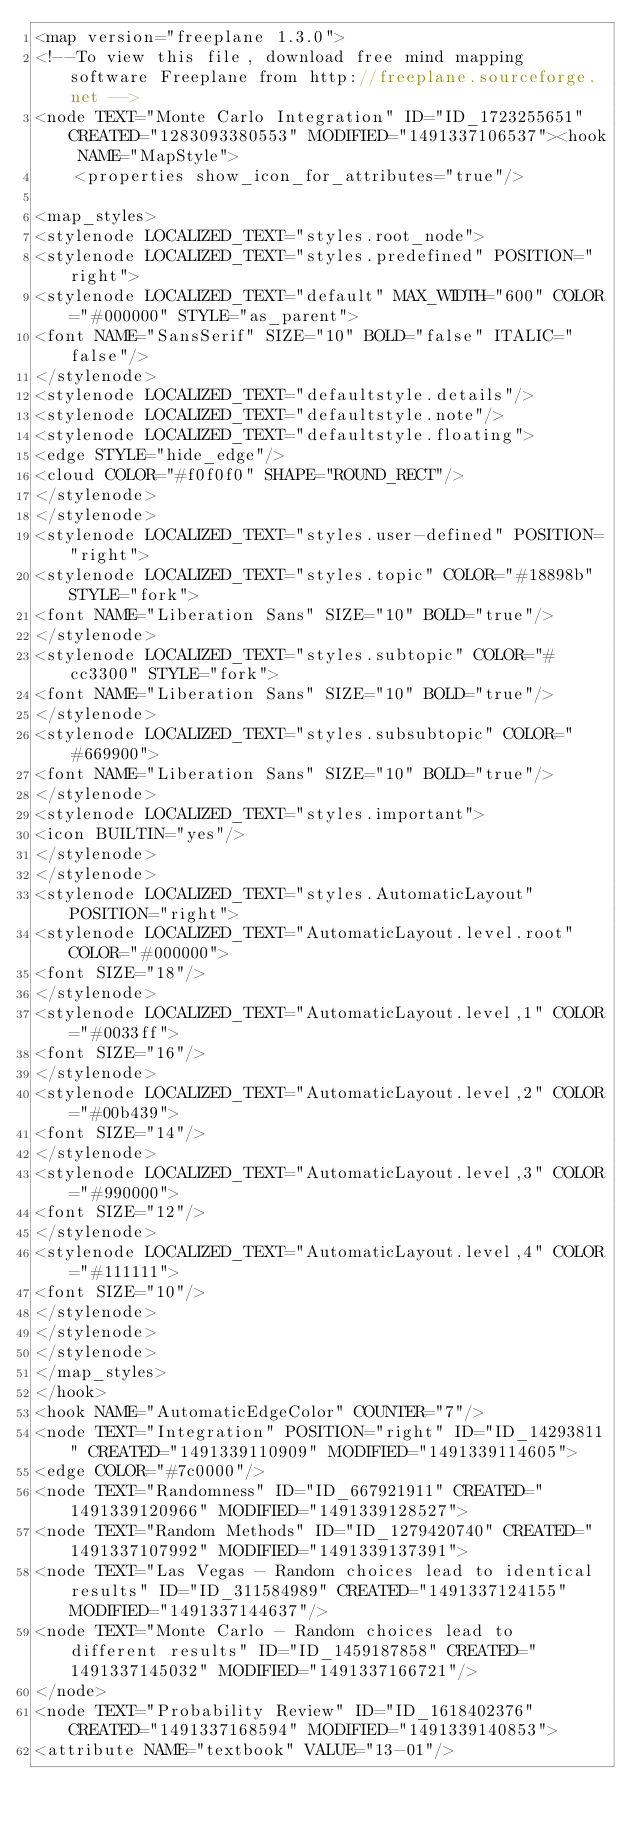<code> <loc_0><loc_0><loc_500><loc_500><_ObjectiveC_><map version="freeplane 1.3.0">
<!--To view this file, download free mind mapping software Freeplane from http://freeplane.sourceforge.net -->
<node TEXT="Monte Carlo Integration" ID="ID_1723255651" CREATED="1283093380553" MODIFIED="1491337106537"><hook NAME="MapStyle">
    <properties show_icon_for_attributes="true"/>

<map_styles>
<stylenode LOCALIZED_TEXT="styles.root_node">
<stylenode LOCALIZED_TEXT="styles.predefined" POSITION="right">
<stylenode LOCALIZED_TEXT="default" MAX_WIDTH="600" COLOR="#000000" STYLE="as_parent">
<font NAME="SansSerif" SIZE="10" BOLD="false" ITALIC="false"/>
</stylenode>
<stylenode LOCALIZED_TEXT="defaultstyle.details"/>
<stylenode LOCALIZED_TEXT="defaultstyle.note"/>
<stylenode LOCALIZED_TEXT="defaultstyle.floating">
<edge STYLE="hide_edge"/>
<cloud COLOR="#f0f0f0" SHAPE="ROUND_RECT"/>
</stylenode>
</stylenode>
<stylenode LOCALIZED_TEXT="styles.user-defined" POSITION="right">
<stylenode LOCALIZED_TEXT="styles.topic" COLOR="#18898b" STYLE="fork">
<font NAME="Liberation Sans" SIZE="10" BOLD="true"/>
</stylenode>
<stylenode LOCALIZED_TEXT="styles.subtopic" COLOR="#cc3300" STYLE="fork">
<font NAME="Liberation Sans" SIZE="10" BOLD="true"/>
</stylenode>
<stylenode LOCALIZED_TEXT="styles.subsubtopic" COLOR="#669900">
<font NAME="Liberation Sans" SIZE="10" BOLD="true"/>
</stylenode>
<stylenode LOCALIZED_TEXT="styles.important">
<icon BUILTIN="yes"/>
</stylenode>
</stylenode>
<stylenode LOCALIZED_TEXT="styles.AutomaticLayout" POSITION="right">
<stylenode LOCALIZED_TEXT="AutomaticLayout.level.root" COLOR="#000000">
<font SIZE="18"/>
</stylenode>
<stylenode LOCALIZED_TEXT="AutomaticLayout.level,1" COLOR="#0033ff">
<font SIZE="16"/>
</stylenode>
<stylenode LOCALIZED_TEXT="AutomaticLayout.level,2" COLOR="#00b439">
<font SIZE="14"/>
</stylenode>
<stylenode LOCALIZED_TEXT="AutomaticLayout.level,3" COLOR="#990000">
<font SIZE="12"/>
</stylenode>
<stylenode LOCALIZED_TEXT="AutomaticLayout.level,4" COLOR="#111111">
<font SIZE="10"/>
</stylenode>
</stylenode>
</stylenode>
</map_styles>
</hook>
<hook NAME="AutomaticEdgeColor" COUNTER="7"/>
<node TEXT="Integration" POSITION="right" ID="ID_14293811" CREATED="1491339110909" MODIFIED="1491339114605">
<edge COLOR="#7c0000"/>
<node TEXT="Randomness" ID="ID_667921911" CREATED="1491339120966" MODIFIED="1491339128527">
<node TEXT="Random Methods" ID="ID_1279420740" CREATED="1491337107992" MODIFIED="1491339137391">
<node TEXT="Las Vegas - Random choices lead to identical results" ID="ID_311584989" CREATED="1491337124155" MODIFIED="1491337144637"/>
<node TEXT="Monte Carlo - Random choices lead to different results" ID="ID_1459187858" CREATED="1491337145032" MODIFIED="1491337166721"/>
</node>
<node TEXT="Probability Review" ID="ID_1618402376" CREATED="1491337168594" MODIFIED="1491339140853">
<attribute NAME="textbook" VALUE="13-01"/></code> 